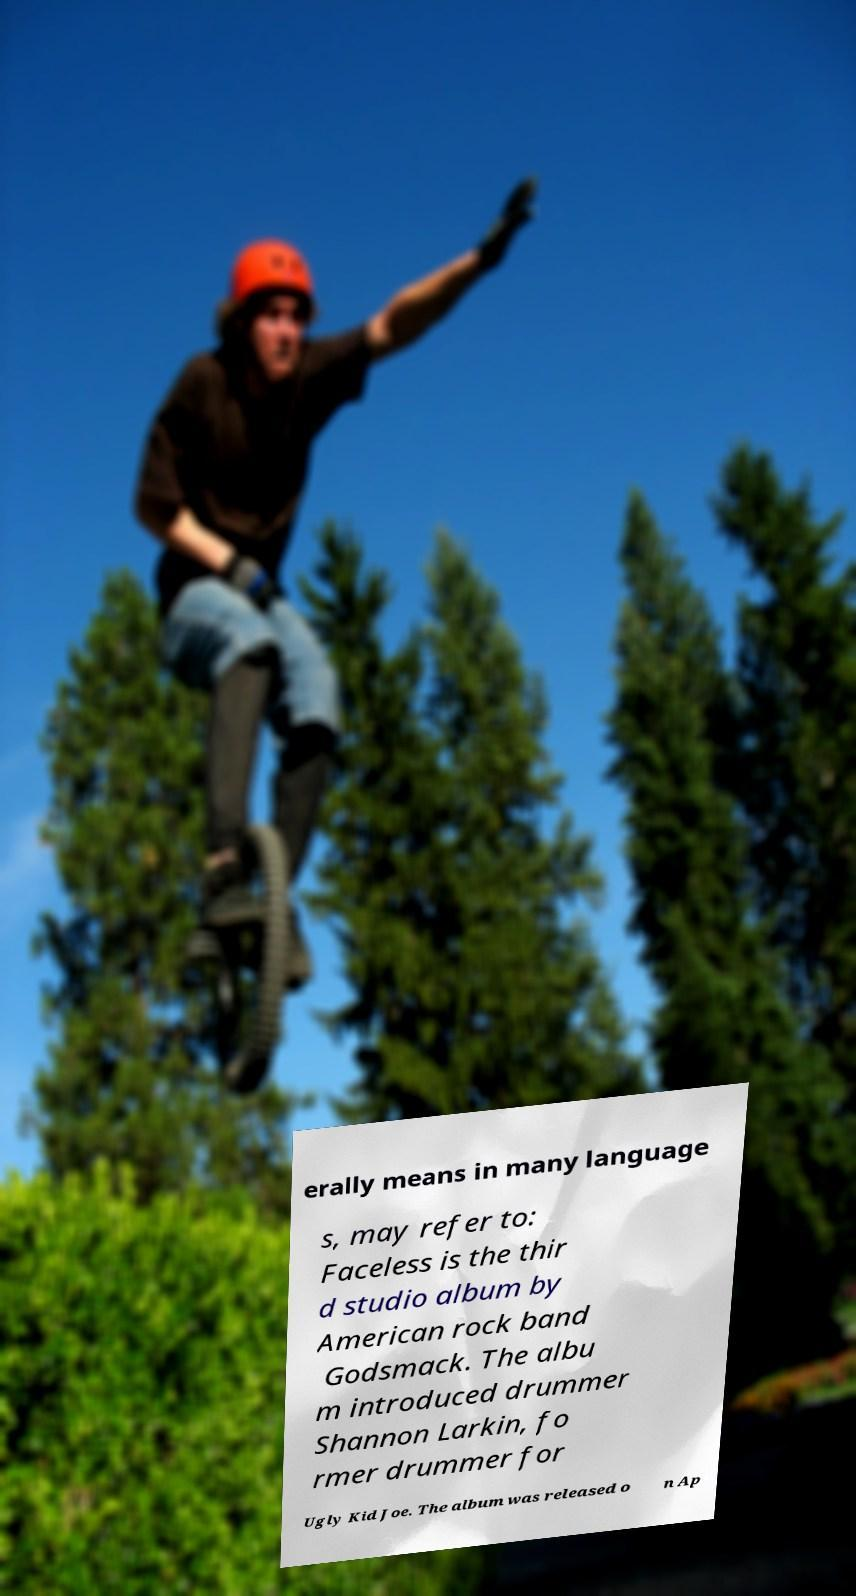For documentation purposes, I need the text within this image transcribed. Could you provide that? erally means in many language s, may refer to: Faceless is the thir d studio album by American rock band Godsmack. The albu m introduced drummer Shannon Larkin, fo rmer drummer for Ugly Kid Joe. The album was released o n Ap 